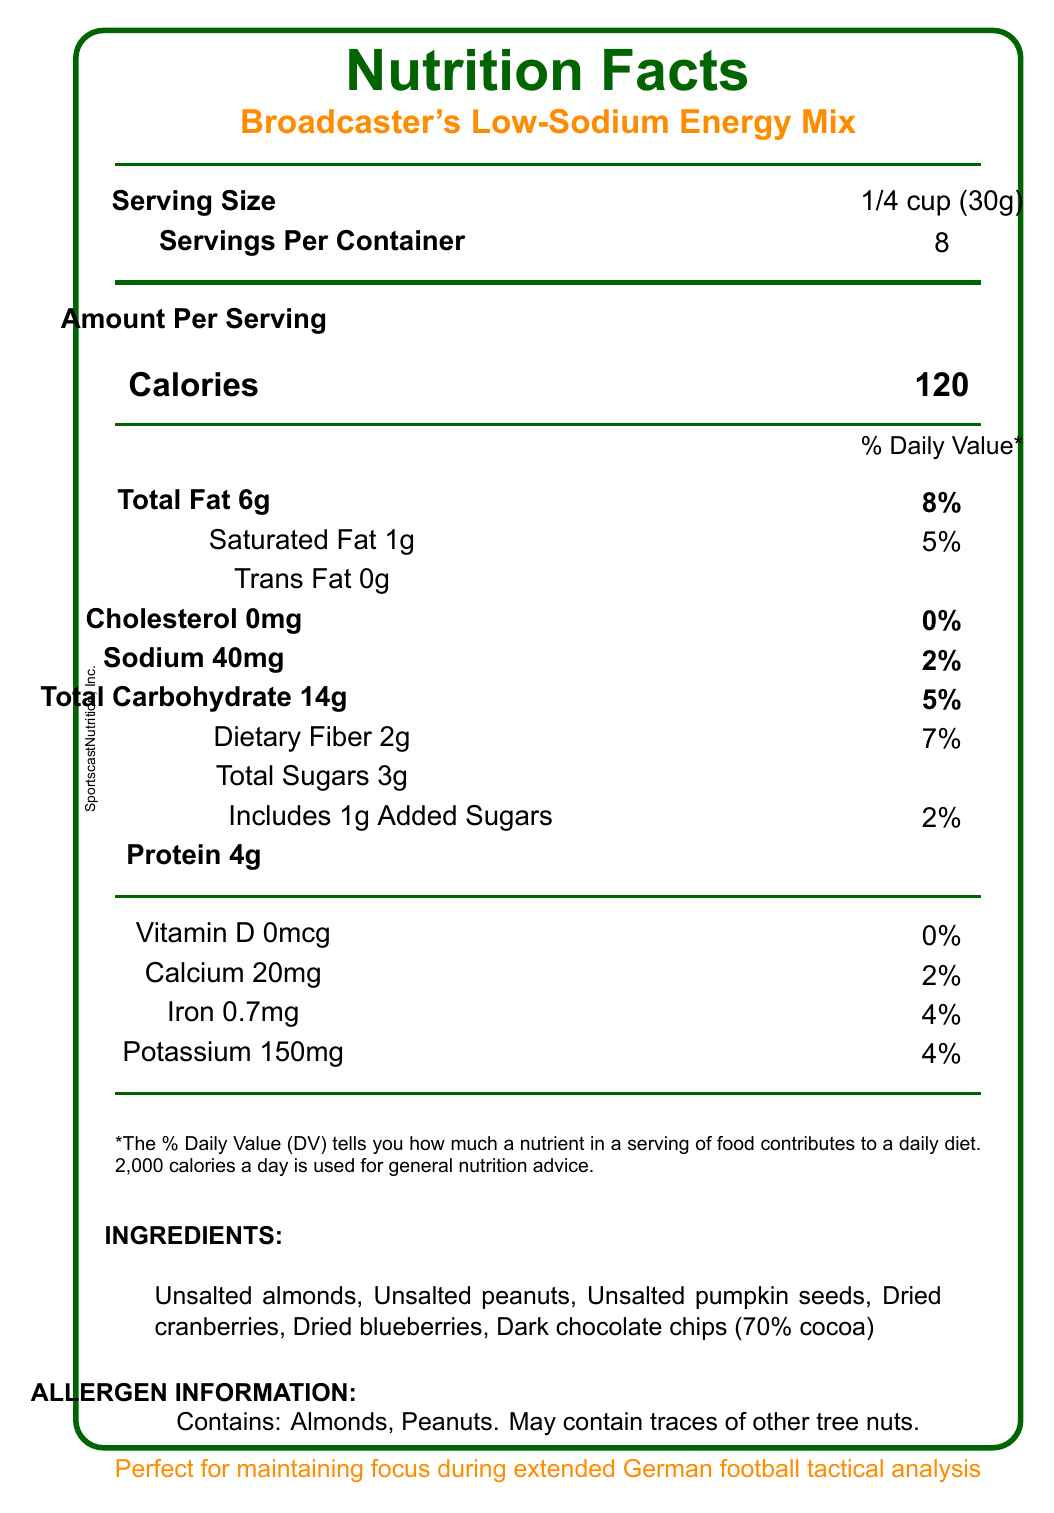what is the serving size of Broadcaster's Low-Sodium Energy Mix? The serving size is listed at the top of the label as 1/4 cup (30g).
Answer: 1/4 cup (30g) how many servings are there per container? The document indicates that there are 8 servings per container.
Answer: 8 what is the total amount of fat per serving? The total fat per serving is provided under the Amount Per Serving section as 6g.
Answer: 6g how much sodium is in each serving? The label lists the sodium content per serving as 40mg under the Amount Per Serving section.
Answer: 40mg what is the percentage of the daily value of dietary fiber per serving? The label states that the dietary fiber content is 2g, which is 7% of the daily value.
Answer: 7% which ingredient contains the most antioxidants? A. Unsalted almonds B. Dark chocolate chips (70% cocoa) C. Dried blueberries D. Unsalted pumpkin seeds Dark chocolate chips (70% cocoa) is mentioned in the product benefits as containing antioxidants.
Answer: B how many calories are there in a single serving? A. 80 B. 120 C. 140 The calories per serving are listed as 120.
Answer: B what nutritional component does not contribute to the daily value percentage? A. Saturated Fat B. Cholesterol C. Carbohydrates Cholesterol is listed with 0% daily value.
Answer: B does the product contain peanuts? The allergen information lists that the product contains peanuts.
Answer: Yes summarize the key nutritional benefits of the Broadcaster's Low-Sodium Energy Mix. The summary covers the document's key benefits like low sodium content, balance of macronutrients, antioxidant presence, and energy support suitable for long-duration work.
Answer: The Broadcaster's Low-Sodium Energy Mix is low in sodium, providing only 40mg per serving. It offers a good balance of macronutrients with 6g of total fat, 14g of carbohydrates, and 4g of protein per serving. The mix includes ingredients rich in antioxidants and provides a combination of quick and slow-release energy sources, suited for long analysis sessions. what are the main ingredients in the Broadcaster's Low-Sodium Energy Mix? The main ingredients are listed towards the bottom of the label.
Answer: Unsalted almonds, Unsalted peanuts, Unsalted pumpkin seeds, Dried cranberries, Dried blueberries, Dark chocolate chips (70% cocoa) how should the product be stored after opening? This information is provided in the storage instructions part of the document.
Answer: Store in a cool, dry place. Reseal bag after opening. who is the manufacturer of Broadcaster's Low-Sodium Energy Mix? The manufacturer is mentioned at the bottom of the label as SportscastNutrition, Inc.
Answer: SportscastNutrition, Inc. what is the total amount of added sugars in a serving? The label lists the amount of added sugars per serving as 1g.
Answer: 1g how much potassium is in each serving? The amount of potassium per serving is listed as 150mg under the Amount Per Serving section.
Answer: 150mg what health aspect does the product primarily support for broadcasters? The product benefits state that the low sodium content supports healthy blood pressure during long analysis sessions.
Answer: Supports healthy blood pressure describe the unique fact related to football mentioned in the document. The football fact section mentions this comparison.
Answer: The energy mix contains as many ingredients as Miroslav Klose scored goals in World Cups, which is 16. how can the % Daily Value of Vitamin C in the mix be described? The document does not provide any information about the Vitamin C content or its % Daily Value.
Answer: Not enough information 